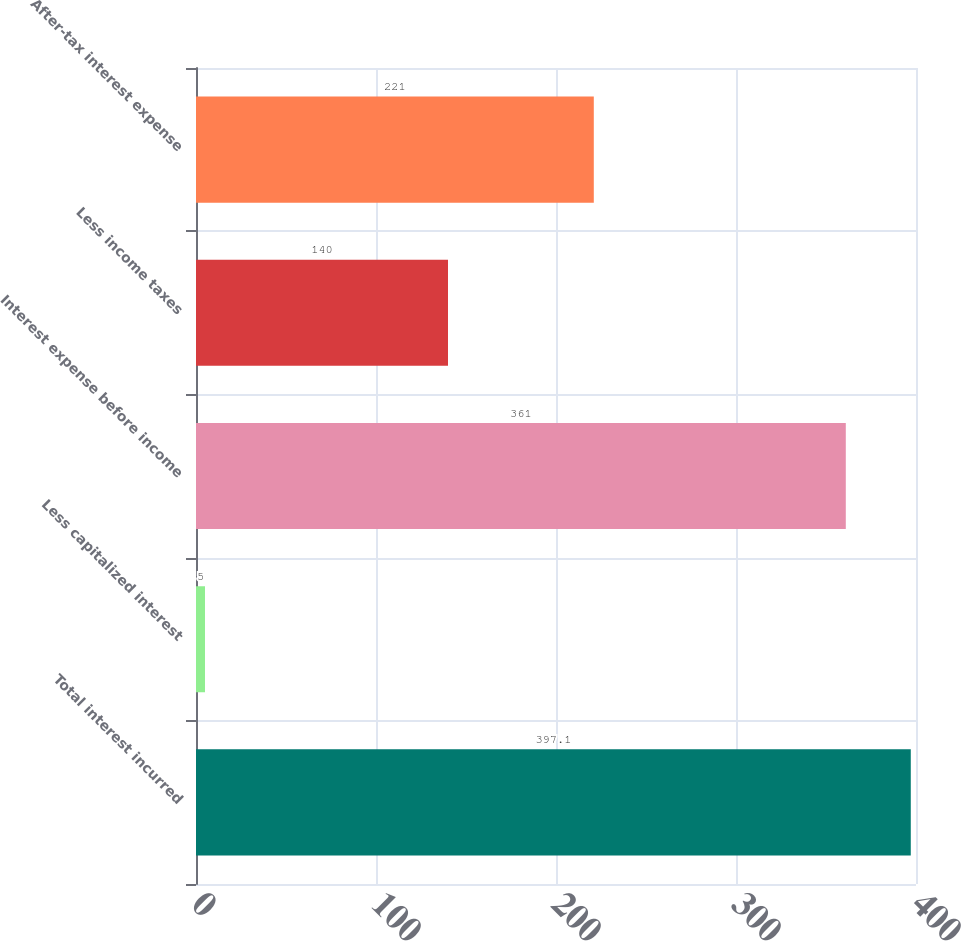Convert chart to OTSL. <chart><loc_0><loc_0><loc_500><loc_500><bar_chart><fcel>Total interest incurred<fcel>Less capitalized interest<fcel>Interest expense before income<fcel>Less income taxes<fcel>After-tax interest expense<nl><fcel>397.1<fcel>5<fcel>361<fcel>140<fcel>221<nl></chart> 